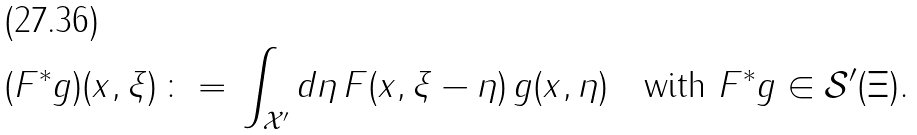<formula> <loc_0><loc_0><loc_500><loc_500>( F ^ { * } g ) ( x , \xi ) \, \colon = \, \int _ { \mathcal { X } ^ { \prime } } d \eta \, F ( x , \xi - \eta ) \, g ( x , \eta ) \quad \text {with } F ^ { * } g \in \mathcal { S } ^ { \prime } ( \Xi ) .</formula> 